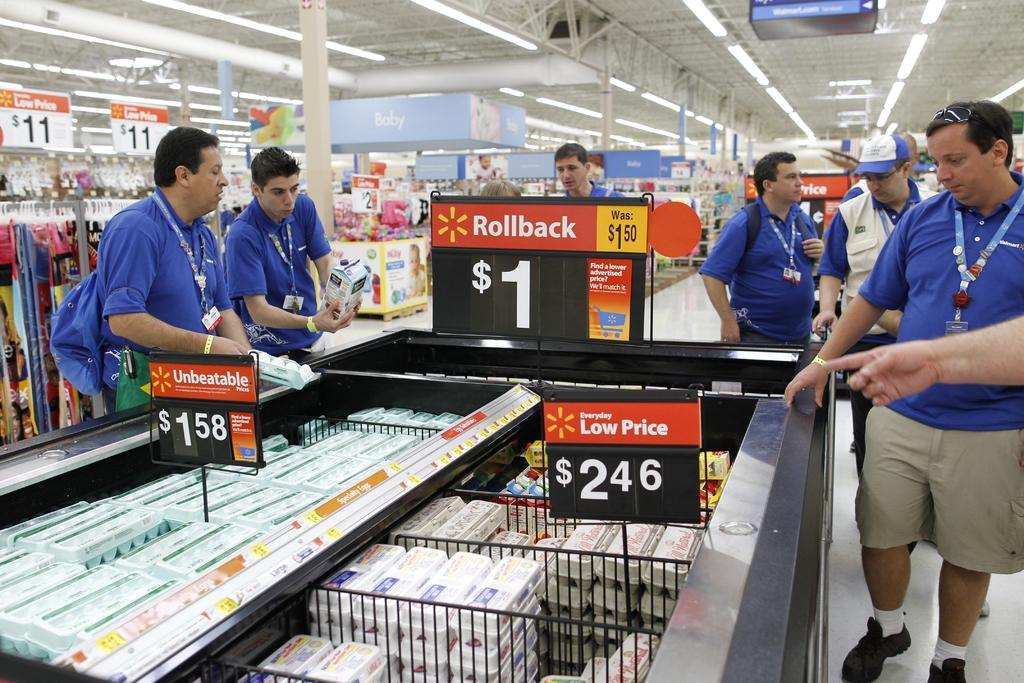<image>
Share a concise interpretation of the image provided. People standing around a store display with a 1 $ price on it 